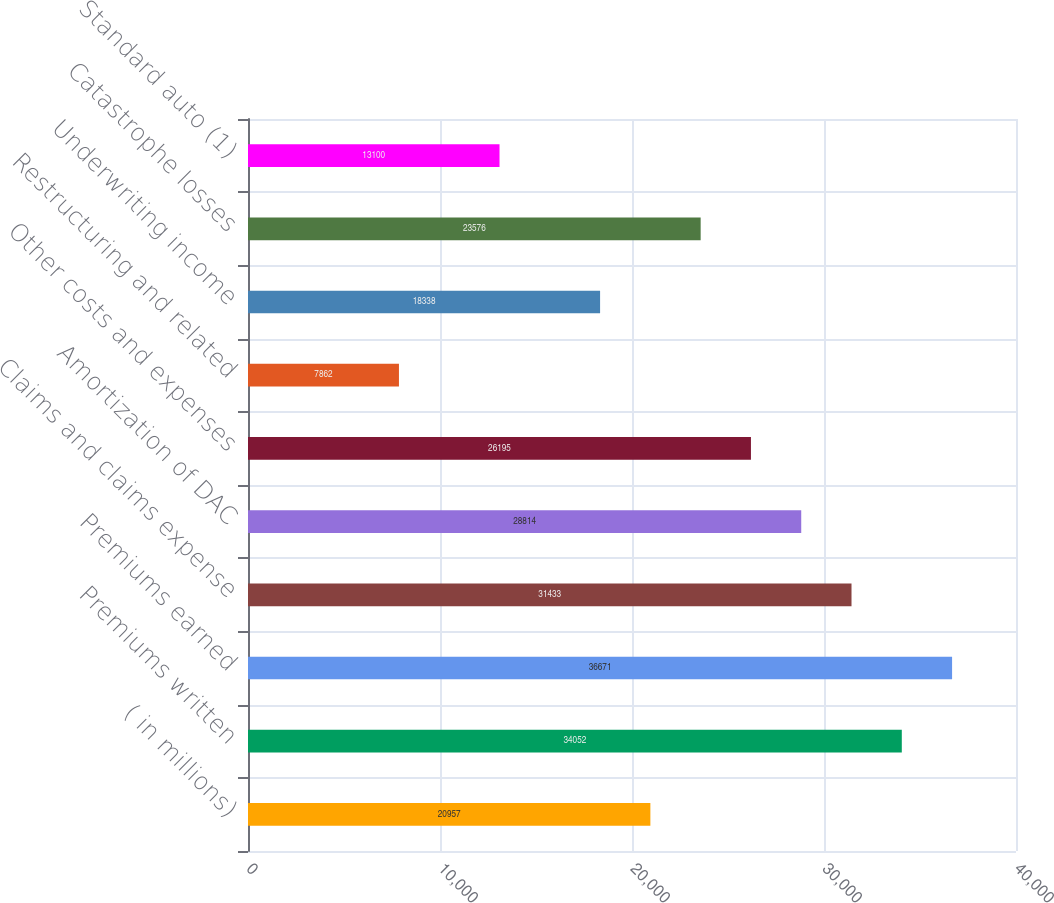Convert chart. <chart><loc_0><loc_0><loc_500><loc_500><bar_chart><fcel>( in millions)<fcel>Premiums written<fcel>Premiums earned<fcel>Claims and claims expense<fcel>Amortization of DAC<fcel>Other costs and expenses<fcel>Restructuring and related<fcel>Underwriting income<fcel>Catastrophe losses<fcel>Standard auto (1)<nl><fcel>20957<fcel>34052<fcel>36671<fcel>31433<fcel>28814<fcel>26195<fcel>7862<fcel>18338<fcel>23576<fcel>13100<nl></chart> 